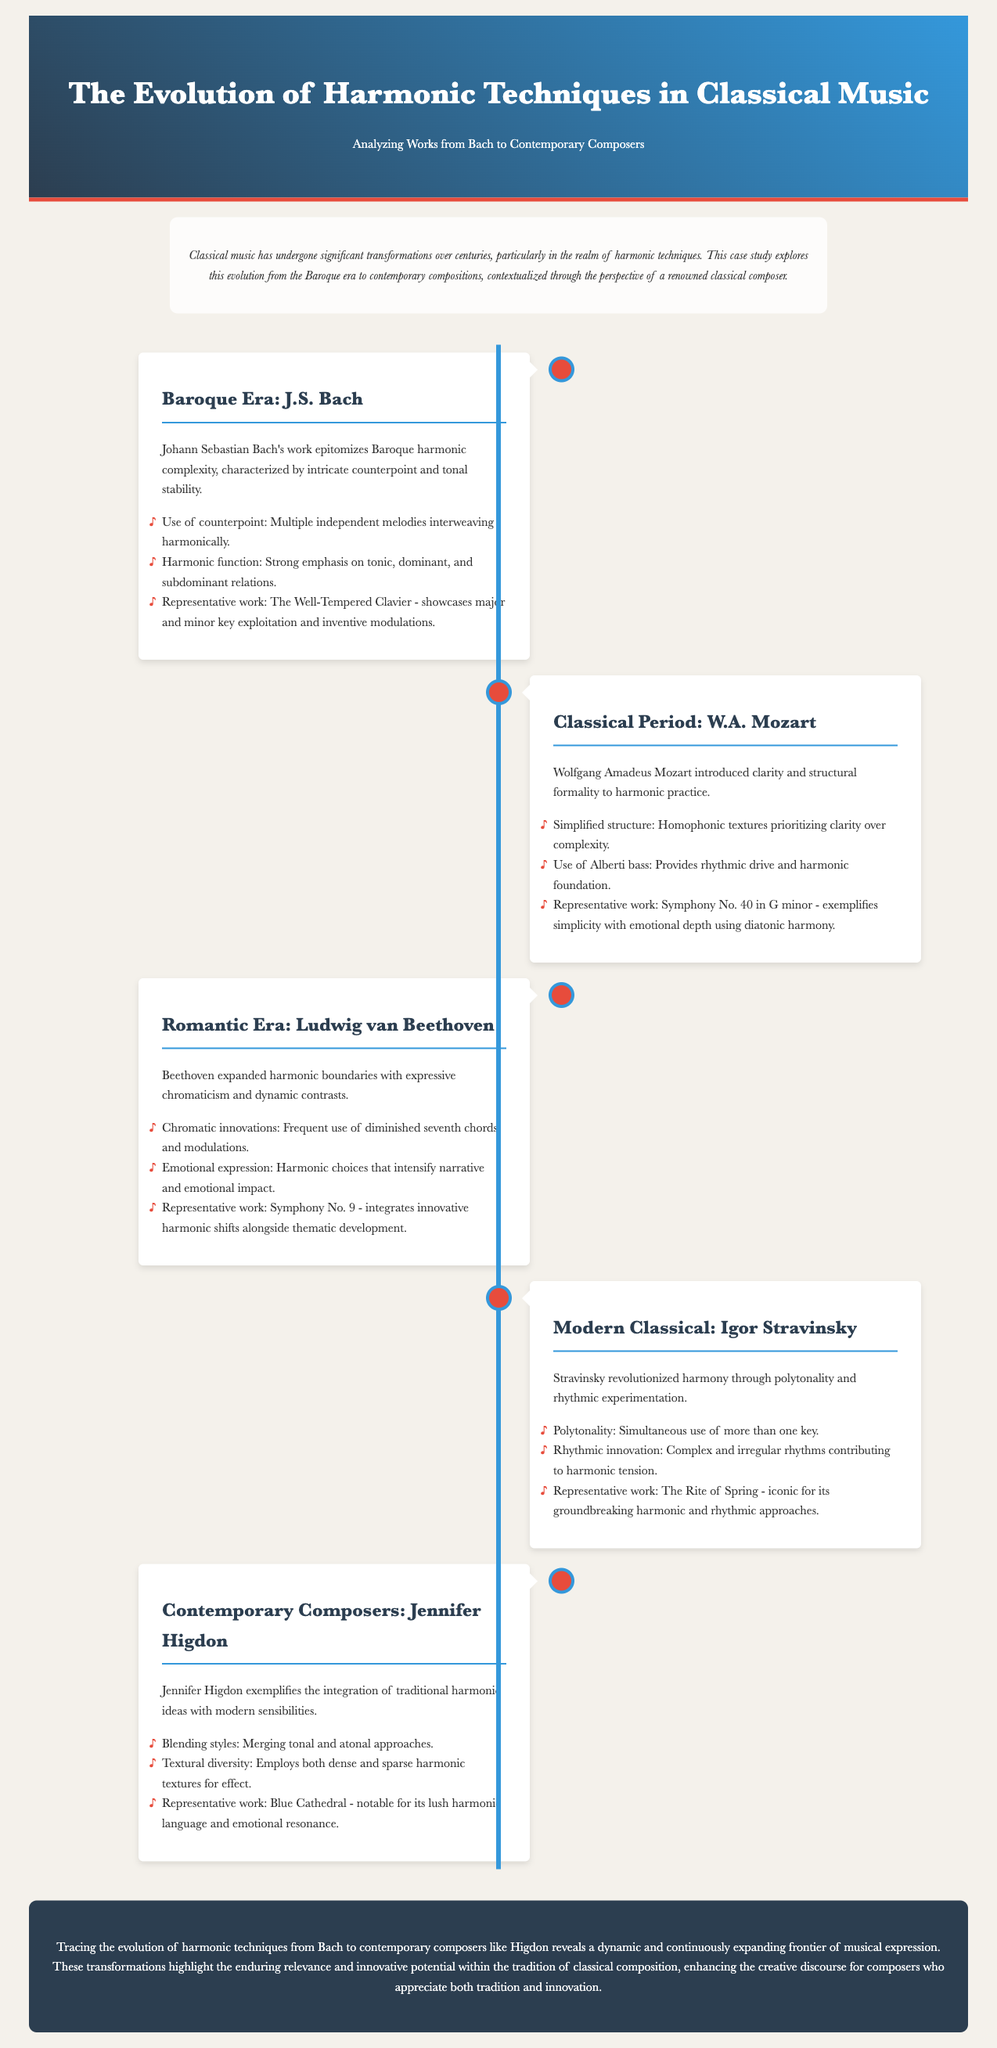What is the representative work of J.S. Bach? The representative work for J.S. Bach is mentioned in the document as "The Well-Tempered Clavier."
Answer: The Well-Tempered Clavier What harmonic technique is associated with Mozart? The document states that Mozart is associated with "Alberti bass."
Answer: Alberti bass Which composer is known for polytonality? The document identifies Igor Stravinsky as the composer known for polytonality.
Answer: Igor Stravinsky What era does Jennifer Higdon represent? The document categorizes Jennifer Higdon under "Contemporary Composers."
Answer: Contemporary Composers How is harmonic complexity described in Bach's work? The document mentions "intricate counterpoint and tonal stability" to describe Bach's harmonic complexity.
Answer: Intricate counterpoint and tonal stability What emotional aspect does Beethoven's harmonic choices intensify? The document states that Beethoven's choices intensify "narrative and emotional impact."
Answer: Narrative and emotional impact Which work exemplifies Mozart's use of diatonic harmony? The work that exemplifies this is "Symphony No. 40 in G minor."
Answer: Symphony No. 40 in G minor What is a hallmark of Jennifer Higdon's harmonic style? The document notes "blending styles" as a hallmark of Higdon's harmonic style.
Answer: Blending styles What is the common thematic focus of the case study? The case study focuses on the "evolution of harmonic techniques."
Answer: Evolution of harmonic techniques 